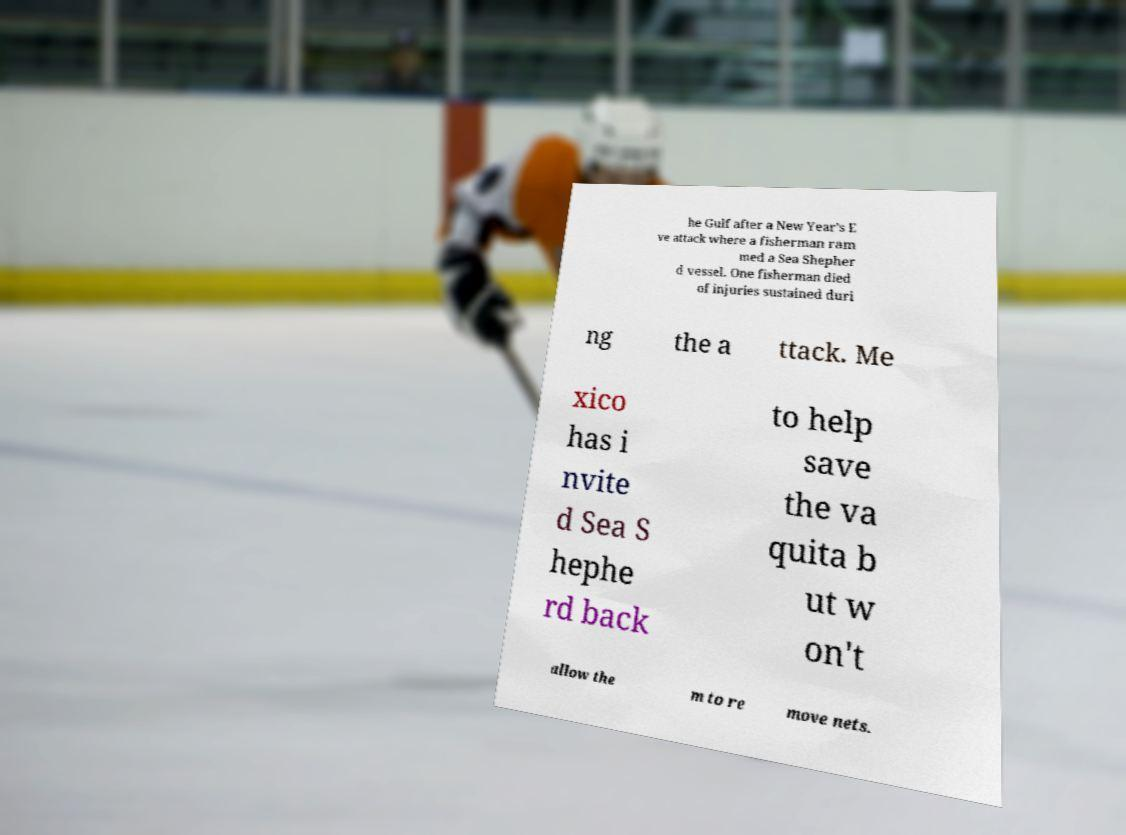What messages or text are displayed in this image? I need them in a readable, typed format. he Gulf after a New Year's E ve attack where a fisherman ram med a Sea Shepher d vessel. One fisherman died of injuries sustained duri ng the a ttack. Me xico has i nvite d Sea S hephe rd back to help save the va quita b ut w on't allow the m to re move nets. 